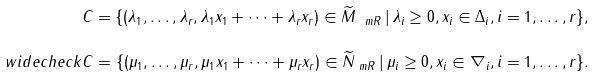Convert formula to latex. <formula><loc_0><loc_0><loc_500><loc_500>C = \{ ( \lambda _ { 1 } , \dots , \lambda _ { r } , \lambda _ { 1 } x _ { 1 } + \dots + \lambda _ { r } x _ { r } ) \in \widetilde { M } _ { \ m R } \, | \, \lambda _ { i } \geq 0 , x _ { i } \in \Delta _ { i } , i = 1 , \dots , r \} , \\ \ w i d e c h e c k C = \{ ( \mu _ { 1 } , \dots , \mu _ { r } , \mu _ { 1 } x _ { 1 } + \dots + \mu _ { r } x _ { r } ) \in \widetilde { N } _ { \ m R } \, | \, \mu _ { i } \geq 0 , x _ { i } \in \nabla _ { i } , i = 1 , \dots , r \} .</formula> 